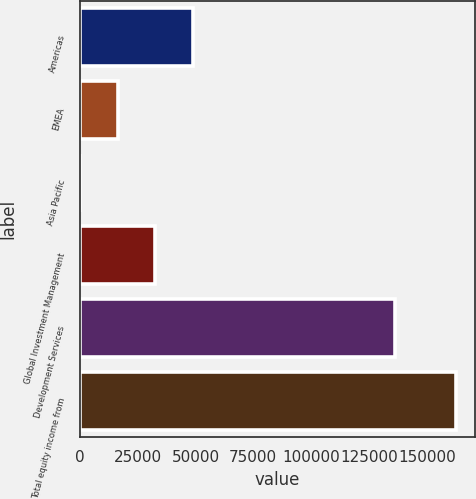<chart> <loc_0><loc_0><loc_500><loc_500><bar_chart><fcel>Americas<fcel>EMEA<fcel>Asia Pacific<fcel>Global Investment Management<fcel>Development Services<fcel>Total equity income from<nl><fcel>48912.8<fcel>16359.6<fcel>83<fcel>32636.2<fcel>136447<fcel>162849<nl></chart> 